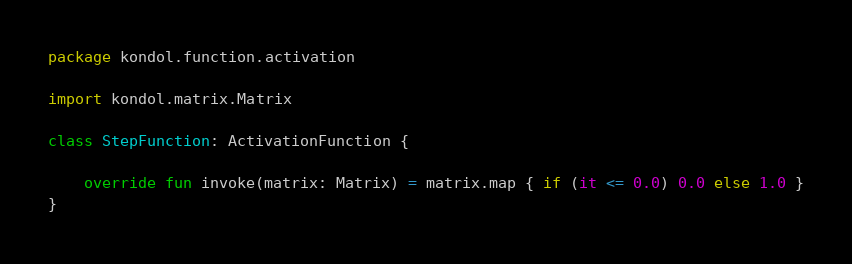<code> <loc_0><loc_0><loc_500><loc_500><_Kotlin_>package kondol.function.activation

import kondol.matrix.Matrix

class StepFunction: ActivationFunction {
    
    override fun invoke(matrix: Matrix) = matrix.map { if (it <= 0.0) 0.0 else 1.0 }
}
</code> 